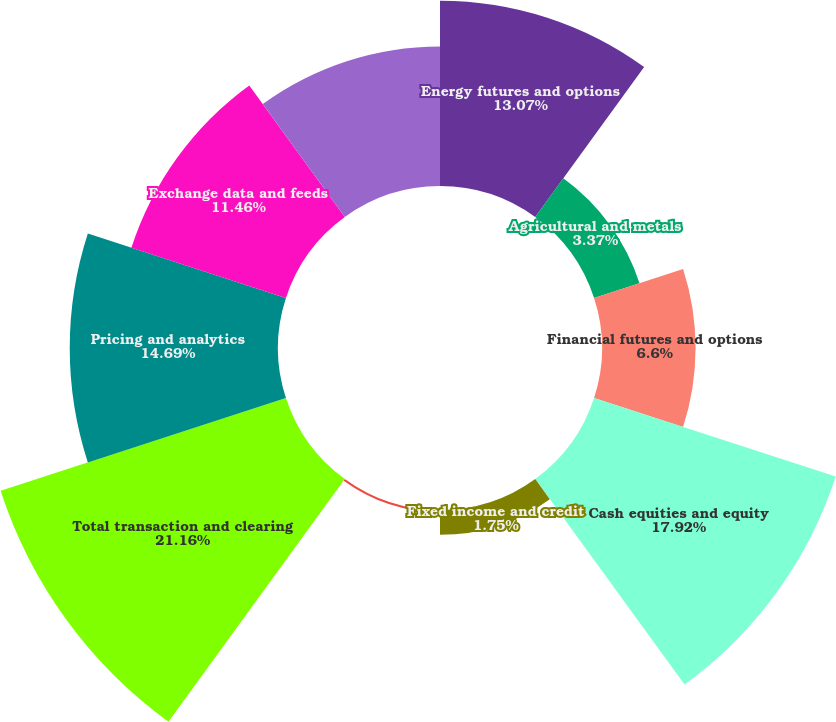<chart> <loc_0><loc_0><loc_500><loc_500><pie_chart><fcel>Energy futures and options<fcel>Agricultural and metals<fcel>Financial futures and options<fcel>Cash equities and equity<fcel>Fixed income and credit<fcel>OTC and other transactions<fcel>Total transaction and clearing<fcel>Pricing and analytics<fcel>Exchange data and feeds<fcel>Desktops and connectivity<nl><fcel>13.07%<fcel>3.37%<fcel>6.6%<fcel>17.92%<fcel>1.75%<fcel>0.14%<fcel>21.16%<fcel>14.69%<fcel>11.46%<fcel>9.84%<nl></chart> 